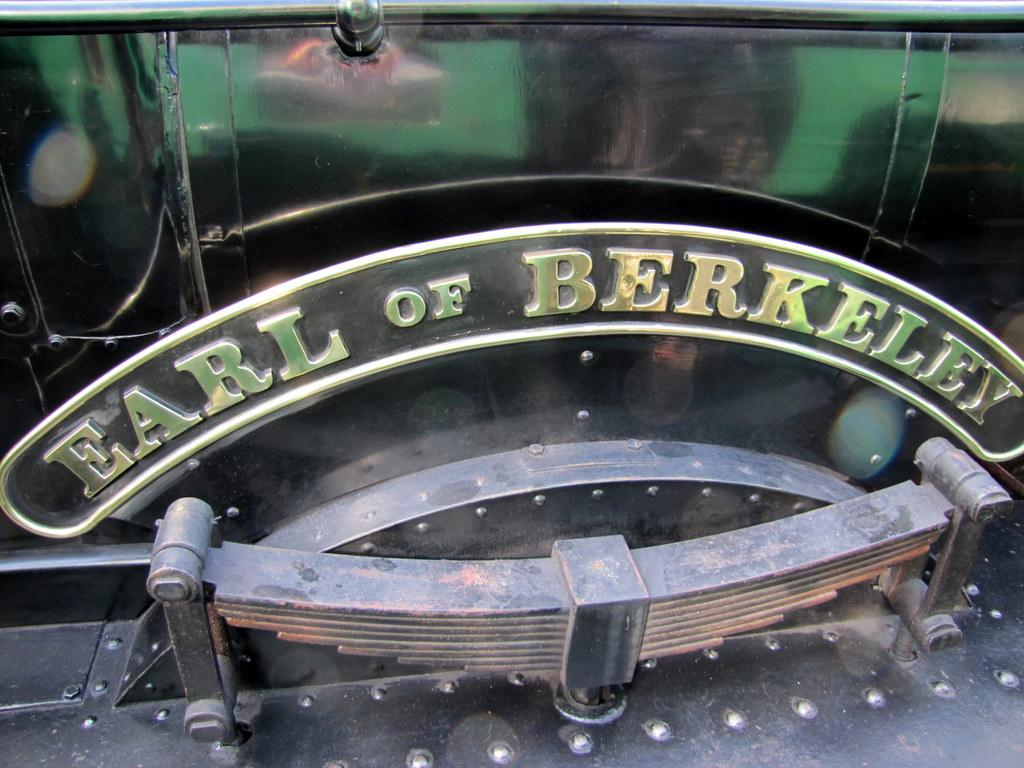What is the main subject of the image? The main subject of the image is a train name plate. Can you describe the train name plate in the image? Unfortunately, the provided facts do not include any details about the train name plate. However, we can confirm that it is the primary focus of the image. What type of soap is being advertised on the train name plate? There is no soap or advertisement present on the train name plate in the image. 